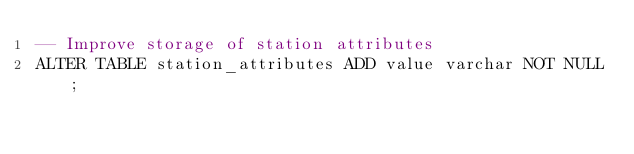Convert code to text. <code><loc_0><loc_0><loc_500><loc_500><_SQL_>-- Improve storage of station attributes
ALTER TABLE station_attributes ADD value varchar NOT NULL;
</code> 